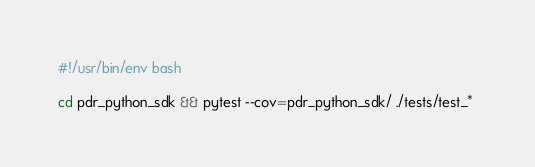<code> <loc_0><loc_0><loc_500><loc_500><_Bash_>#!/usr/bin/env bash

cd pdr_python_sdk && pytest --cov=pdr_python_sdk/ ./tests/test_* </code> 